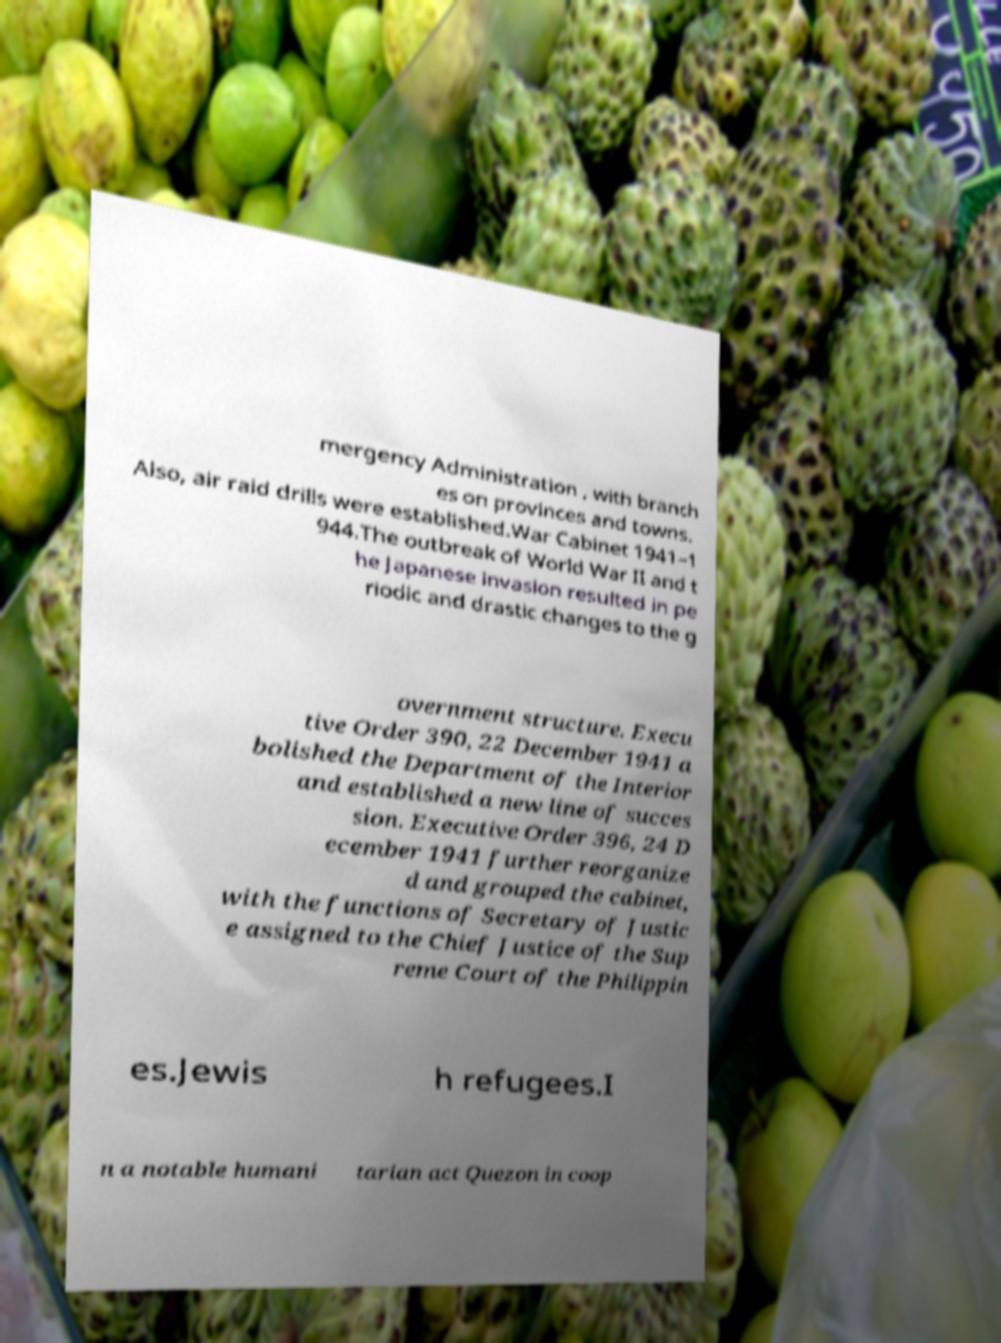For documentation purposes, I need the text within this image transcribed. Could you provide that? mergency Administration , with branch es on provinces and towns. Also, air raid drills were established.War Cabinet 1941–1 944.The outbreak of World War II and t he Japanese invasion resulted in pe riodic and drastic changes to the g overnment structure. Execu tive Order 390, 22 December 1941 a bolished the Department of the Interior and established a new line of succes sion. Executive Order 396, 24 D ecember 1941 further reorganize d and grouped the cabinet, with the functions of Secretary of Justic e assigned to the Chief Justice of the Sup reme Court of the Philippin es.Jewis h refugees.I n a notable humani tarian act Quezon in coop 